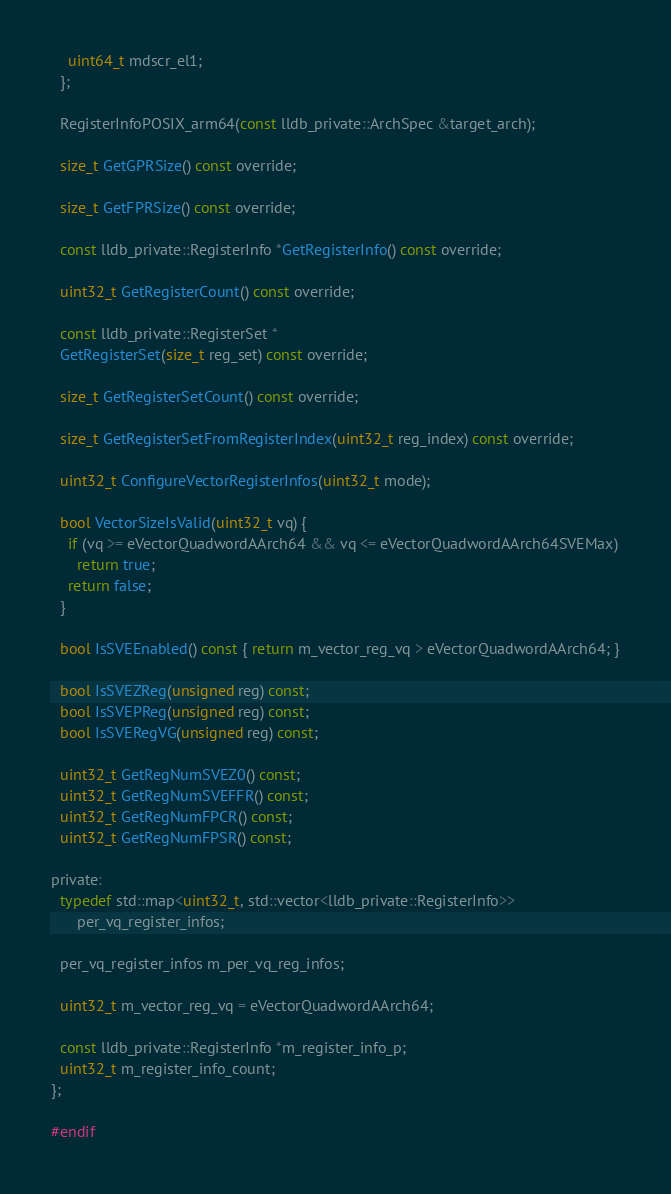<code> <loc_0><loc_0><loc_500><loc_500><_C_>    uint64_t mdscr_el1;
  };

  RegisterInfoPOSIX_arm64(const lldb_private::ArchSpec &target_arch);

  size_t GetGPRSize() const override;

  size_t GetFPRSize() const override;

  const lldb_private::RegisterInfo *GetRegisterInfo() const override;

  uint32_t GetRegisterCount() const override;

  const lldb_private::RegisterSet *
  GetRegisterSet(size_t reg_set) const override;

  size_t GetRegisterSetCount() const override;

  size_t GetRegisterSetFromRegisterIndex(uint32_t reg_index) const override;

  uint32_t ConfigureVectorRegisterInfos(uint32_t mode);

  bool VectorSizeIsValid(uint32_t vq) {
    if (vq >= eVectorQuadwordAArch64 && vq <= eVectorQuadwordAArch64SVEMax)
      return true;
    return false;
  }

  bool IsSVEEnabled() const { return m_vector_reg_vq > eVectorQuadwordAArch64; }

  bool IsSVEZReg(unsigned reg) const;
  bool IsSVEPReg(unsigned reg) const;
  bool IsSVERegVG(unsigned reg) const;

  uint32_t GetRegNumSVEZ0() const;
  uint32_t GetRegNumSVEFFR() const;
  uint32_t GetRegNumFPCR() const;
  uint32_t GetRegNumFPSR() const;

private:
  typedef std::map<uint32_t, std::vector<lldb_private::RegisterInfo>>
      per_vq_register_infos;

  per_vq_register_infos m_per_vq_reg_infos;

  uint32_t m_vector_reg_vq = eVectorQuadwordAArch64;

  const lldb_private::RegisterInfo *m_register_info_p;
  uint32_t m_register_info_count;
};

#endif
</code> 